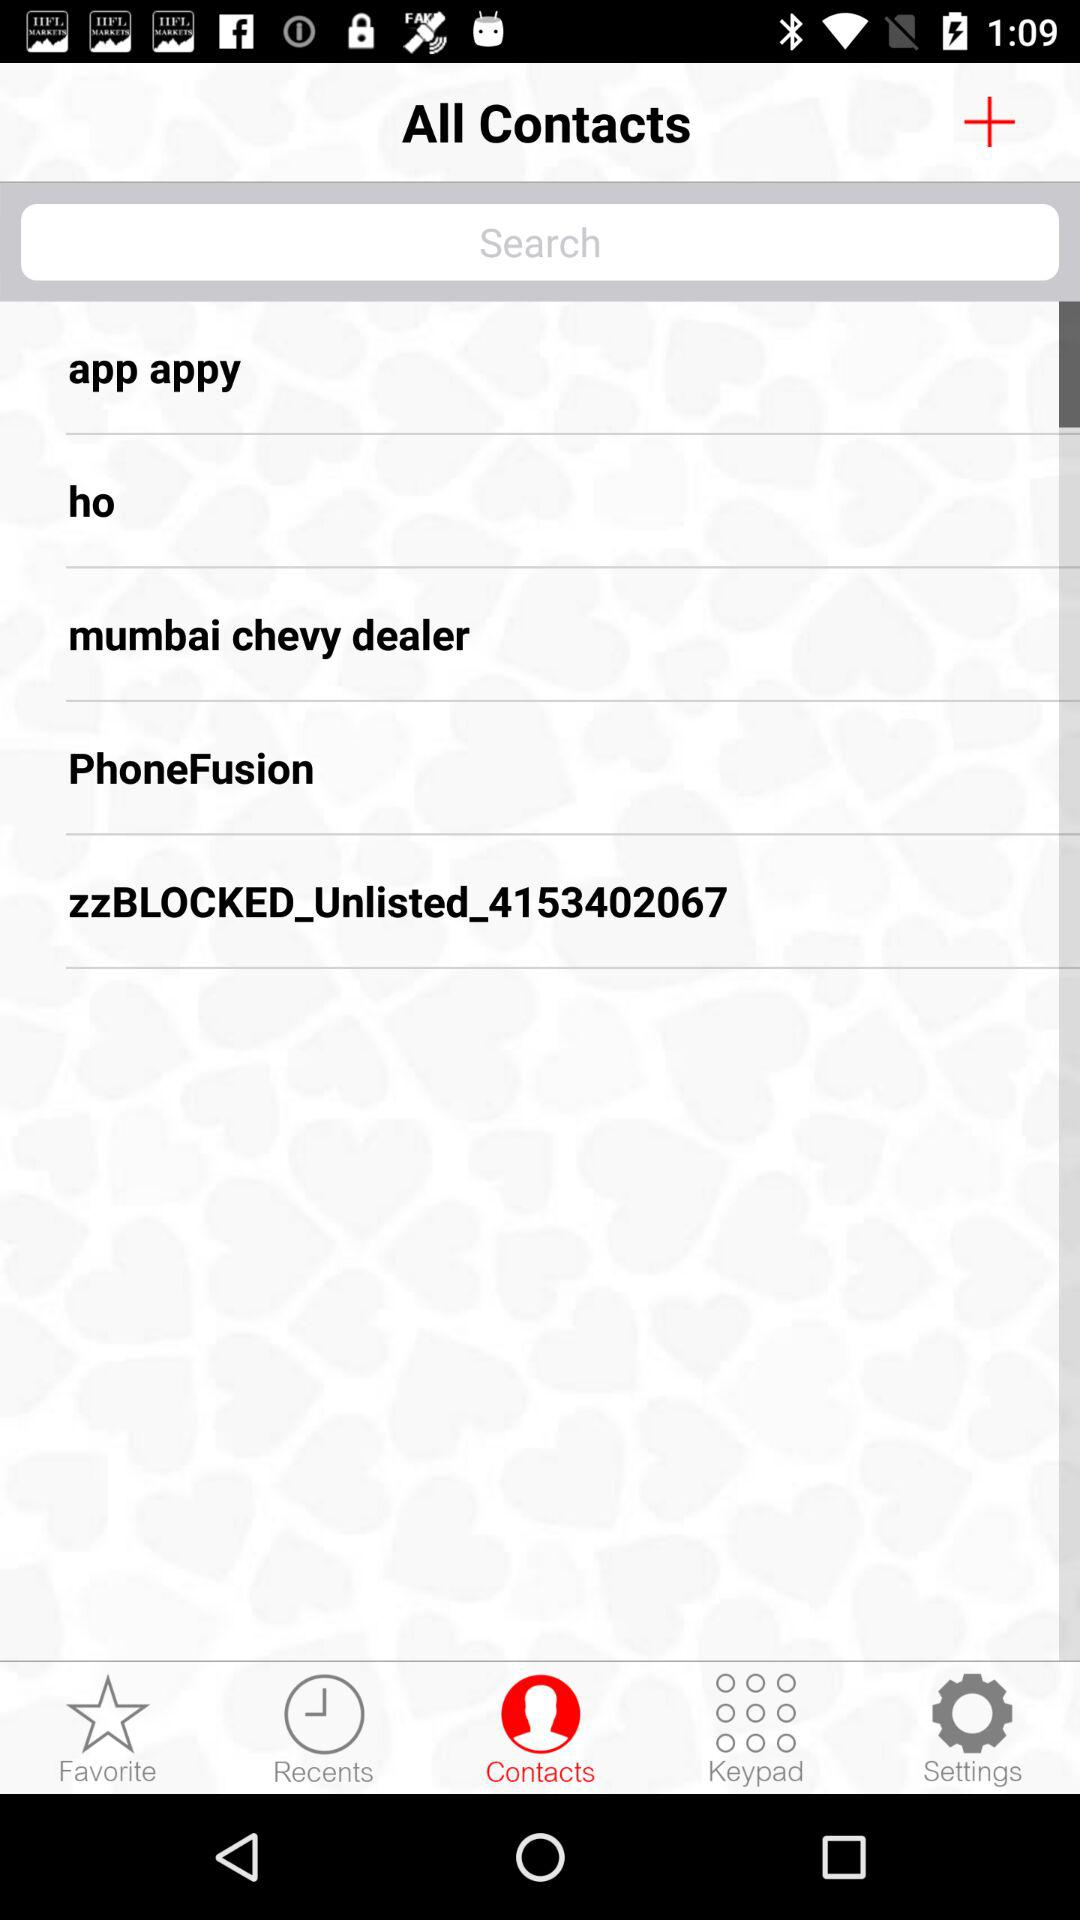Which tab is selected? The selected tab is "Contacts". 